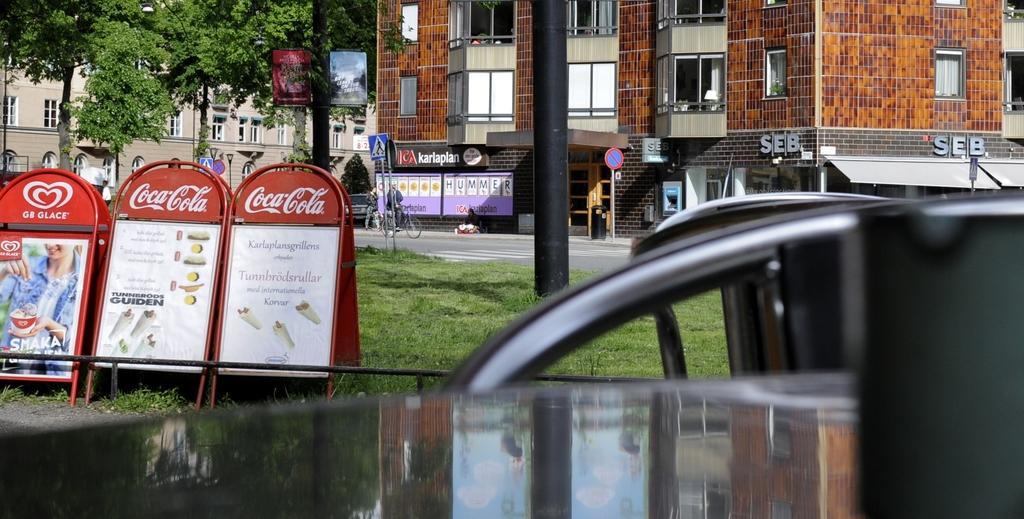Please provide a concise description of this image. In this picture we can see there are boards, poles with sign boards and a person is riding a bicycle and other people are on the path. Behind the people there are trees, buildings, banners and a dustbin. In front of the boards, there is an object. 